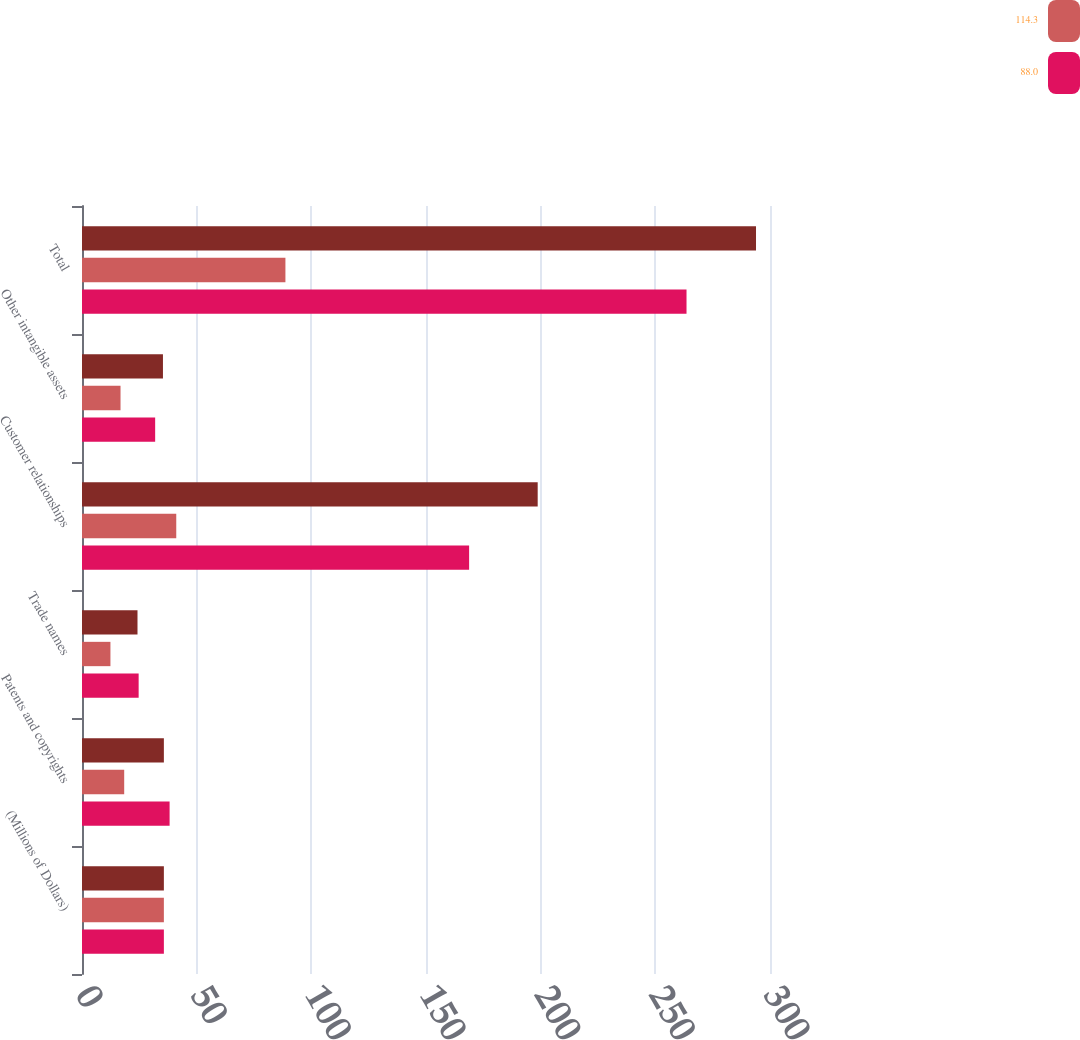Convert chart to OTSL. <chart><loc_0><loc_0><loc_500><loc_500><stacked_bar_chart><ecel><fcel>(Millions of Dollars)<fcel>Patents and copyrights<fcel>Trade names<fcel>Customer relationships<fcel>Other intangible assets<fcel>Total<nl><fcel>nan<fcel>35.7<fcel>35.7<fcel>24.2<fcel>198.7<fcel>35.3<fcel>293.9<nl><fcel>114.3<fcel>35.7<fcel>18.4<fcel>12.4<fcel>41.1<fcel>16.8<fcel>88.7<nl><fcel>88<fcel>35.7<fcel>38.2<fcel>24.7<fcel>168.8<fcel>31.9<fcel>263.6<nl></chart> 